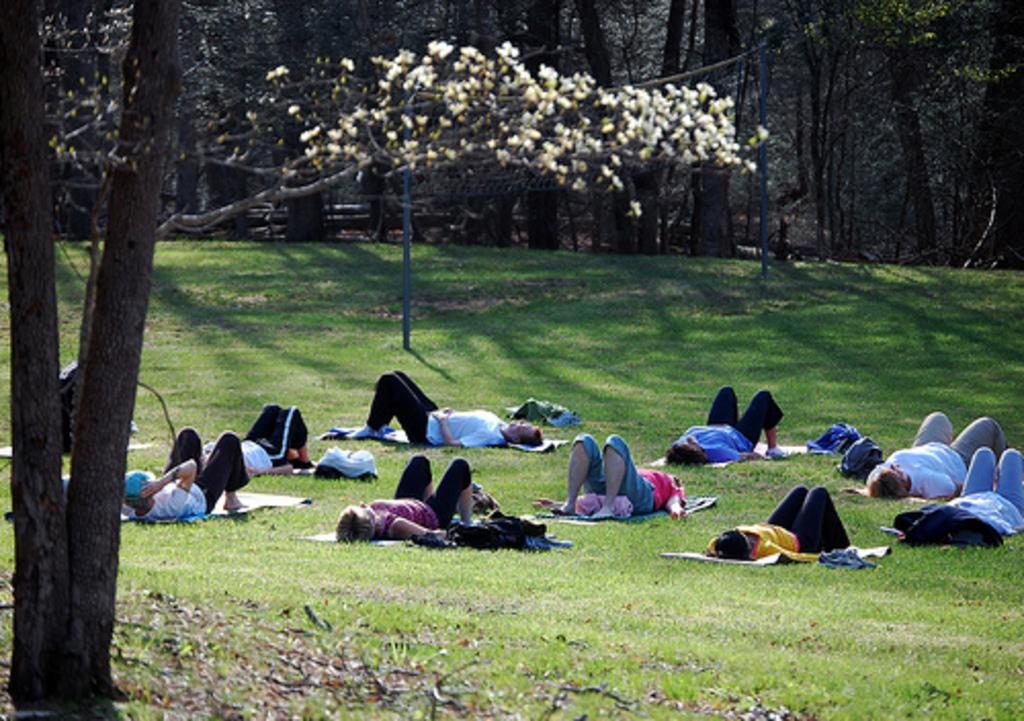What is the main subject of the image? The main subject of the image is a group of people. What are the people in the image doing? The people are lying on the grass. What can be seen in the background of the image? There are trees in the background of the image. What type of religious ceremony is taking place in the image? There is no indication of a religious ceremony in the image; the people are simply lying on the grass. What is the wrist size of the person lying on the right side of the image? There is no information about wrist size in the image, as it focuses on the people lying on the grass and the trees in the background. 